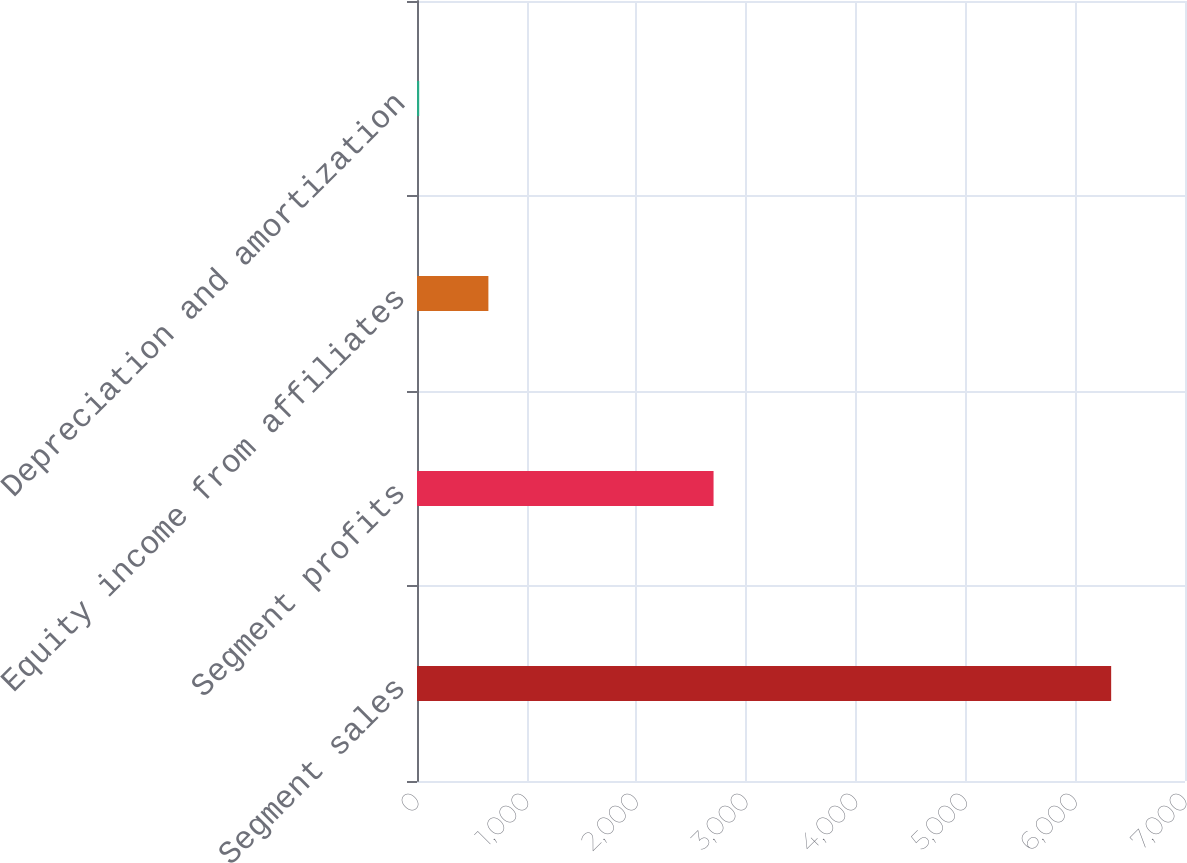Convert chart to OTSL. <chart><loc_0><loc_0><loc_500><loc_500><bar_chart><fcel>Segment sales<fcel>Segment profits<fcel>Equity income from affiliates<fcel>Depreciation and amortization<nl><fcel>6327<fcel>2703<fcel>650.7<fcel>20<nl></chart> 